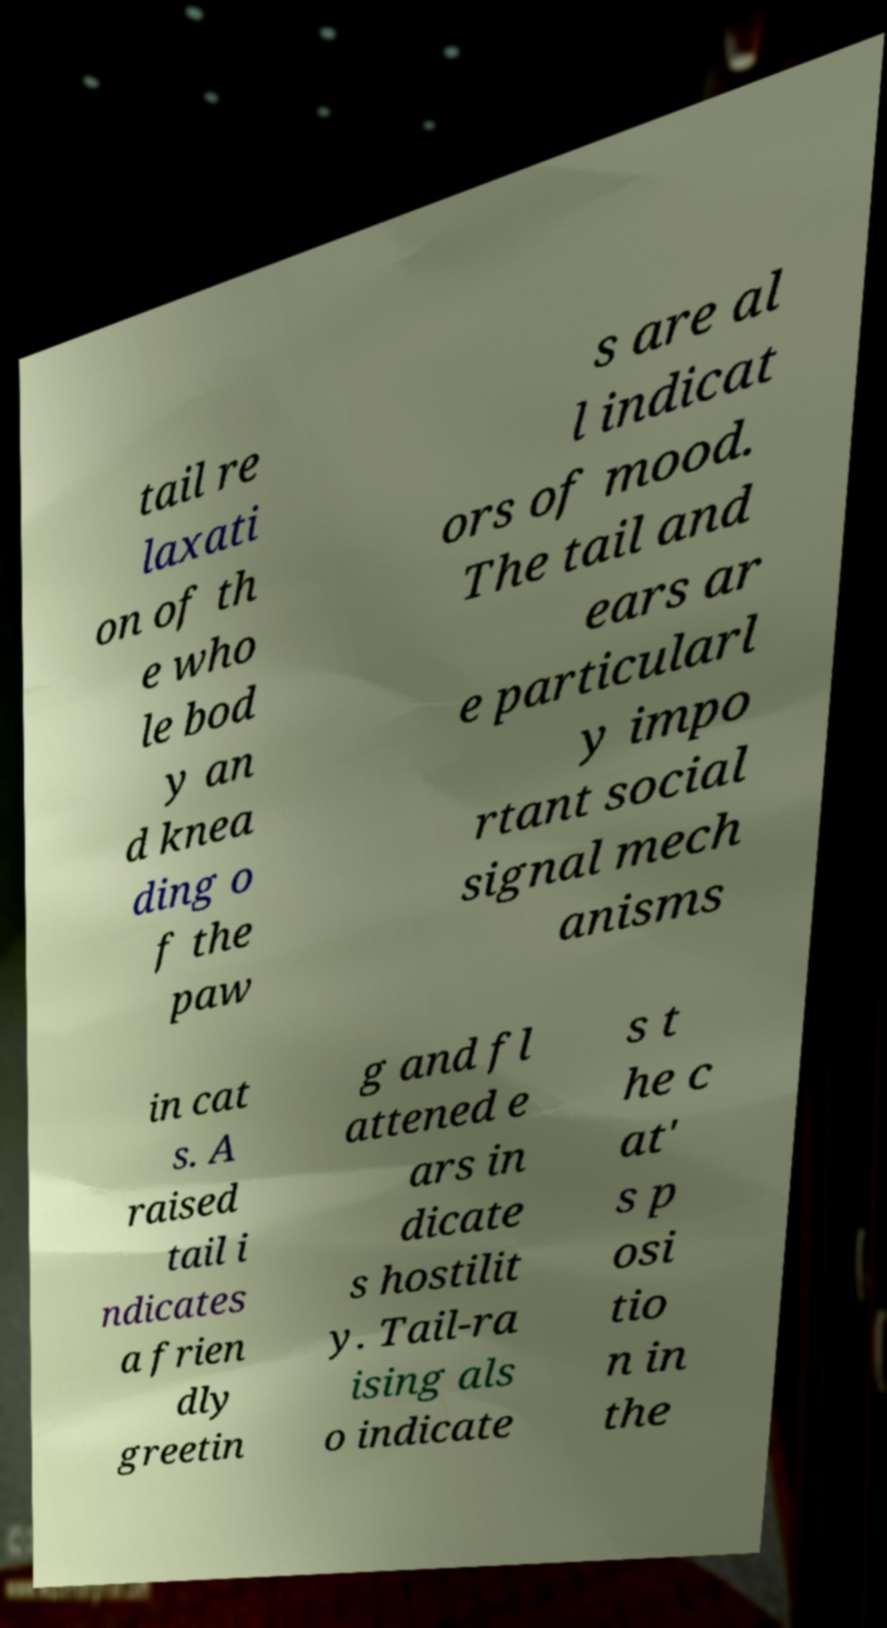Please identify and transcribe the text found in this image. tail re laxati on of th e who le bod y an d knea ding o f the paw s are al l indicat ors of mood. The tail and ears ar e particularl y impo rtant social signal mech anisms in cat s. A raised tail i ndicates a frien dly greetin g and fl attened e ars in dicate s hostilit y. Tail-ra ising als o indicate s t he c at' s p osi tio n in the 